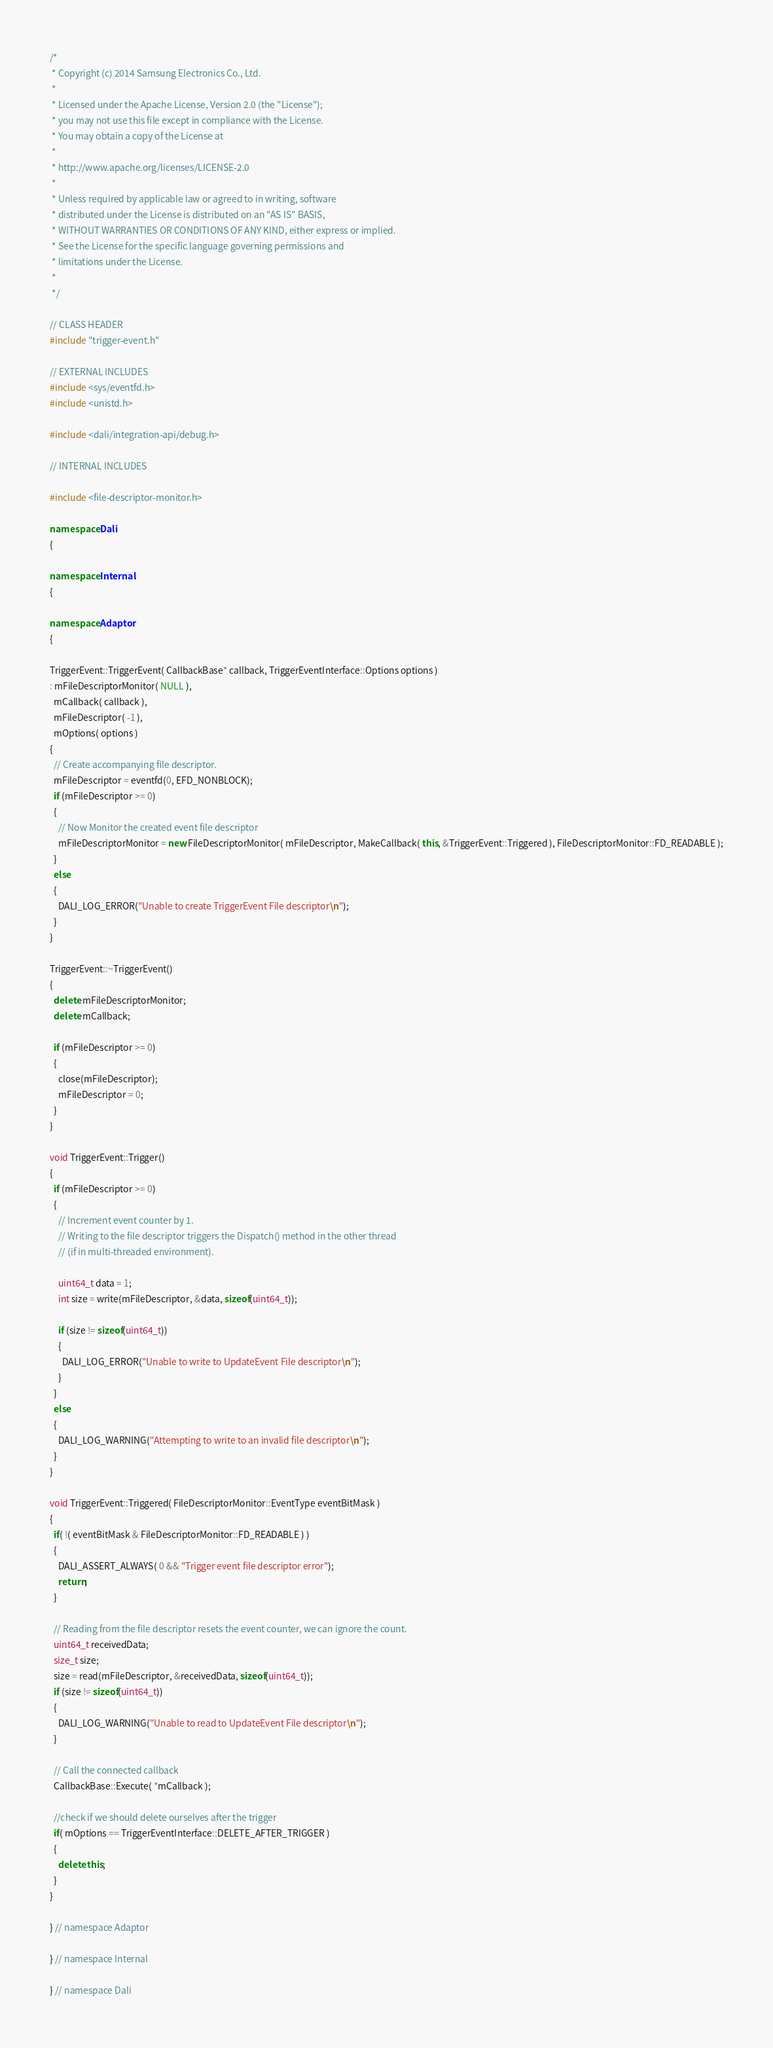Convert code to text. <code><loc_0><loc_0><loc_500><loc_500><_C++_>/*
 * Copyright (c) 2014 Samsung Electronics Co., Ltd.
 *
 * Licensed under the Apache License, Version 2.0 (the "License");
 * you may not use this file except in compliance with the License.
 * You may obtain a copy of the License at
 *
 * http://www.apache.org/licenses/LICENSE-2.0
 *
 * Unless required by applicable law or agreed to in writing, software
 * distributed under the License is distributed on an "AS IS" BASIS,
 * WITHOUT WARRANTIES OR CONDITIONS OF ANY KIND, either express or implied.
 * See the License for the specific language governing permissions and
 * limitations under the License.
 *
 */

// CLASS HEADER
#include "trigger-event.h"

// EXTERNAL INCLUDES
#include <sys/eventfd.h>
#include <unistd.h>

#include <dali/integration-api/debug.h>

// INTERNAL INCLUDES

#include <file-descriptor-monitor.h>

namespace Dali
{

namespace Internal
{

namespace Adaptor
{

TriggerEvent::TriggerEvent( CallbackBase* callback, TriggerEventInterface::Options options )
: mFileDescriptorMonitor( NULL ),
  mCallback( callback ),
  mFileDescriptor( -1 ),
  mOptions( options )
{
  // Create accompanying file descriptor.
  mFileDescriptor = eventfd(0, EFD_NONBLOCK);
  if (mFileDescriptor >= 0)
  {
    // Now Monitor the created event file descriptor
    mFileDescriptorMonitor = new FileDescriptorMonitor( mFileDescriptor, MakeCallback( this, &TriggerEvent::Triggered ), FileDescriptorMonitor::FD_READABLE );
  }
  else
  {
    DALI_LOG_ERROR("Unable to create TriggerEvent File descriptor\n");
  }
}

TriggerEvent::~TriggerEvent()
{
  delete mFileDescriptorMonitor;
  delete mCallback;

  if (mFileDescriptor >= 0)
  {
    close(mFileDescriptor);
    mFileDescriptor = 0;
  }
}

void TriggerEvent::Trigger()
{
  if (mFileDescriptor >= 0)
  {
    // Increment event counter by 1.
    // Writing to the file descriptor triggers the Dispatch() method in the other thread
    // (if in multi-threaded environment).

    uint64_t data = 1;
    int size = write(mFileDescriptor, &data, sizeof(uint64_t));

    if (size != sizeof(uint64_t))
    {
      DALI_LOG_ERROR("Unable to write to UpdateEvent File descriptor\n");
    }
  }
  else
  {
    DALI_LOG_WARNING("Attempting to write to an invalid file descriptor\n");
  }
}

void TriggerEvent::Triggered( FileDescriptorMonitor::EventType eventBitMask )
{
  if( !( eventBitMask & FileDescriptorMonitor::FD_READABLE ) )
  {
    DALI_ASSERT_ALWAYS( 0 && "Trigger event file descriptor error");
    return;
  }

  // Reading from the file descriptor resets the event counter, we can ignore the count.
  uint64_t receivedData;
  size_t size;
  size = read(mFileDescriptor, &receivedData, sizeof(uint64_t));
  if (size != sizeof(uint64_t))
  {
    DALI_LOG_WARNING("Unable to read to UpdateEvent File descriptor\n");
  }

  // Call the connected callback
  CallbackBase::Execute( *mCallback );

  //check if we should delete ourselves after the trigger
  if( mOptions == TriggerEventInterface::DELETE_AFTER_TRIGGER )
  {
    delete this;
  }
}

} // namespace Adaptor

} // namespace Internal

} // namespace Dali
</code> 